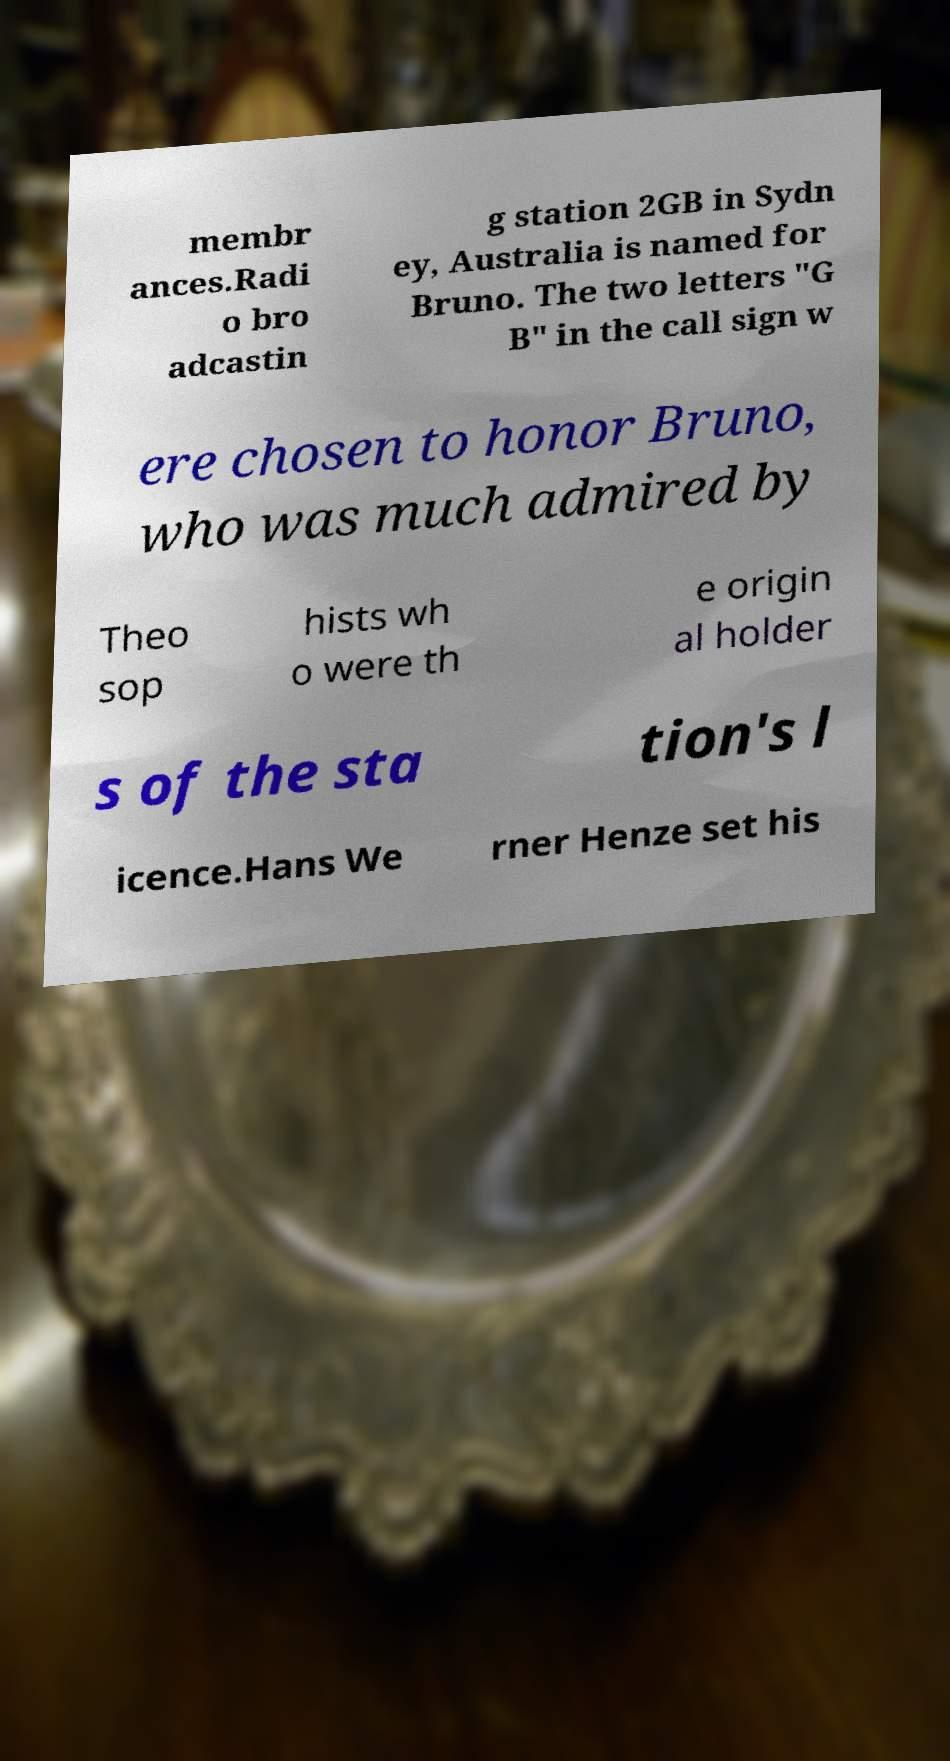I need the written content from this picture converted into text. Can you do that? membr ances.Radi o bro adcastin g station 2GB in Sydn ey, Australia is named for Bruno. The two letters "G B" in the call sign w ere chosen to honor Bruno, who was much admired by Theo sop hists wh o were th e origin al holder s of the sta tion's l icence.Hans We rner Henze set his 